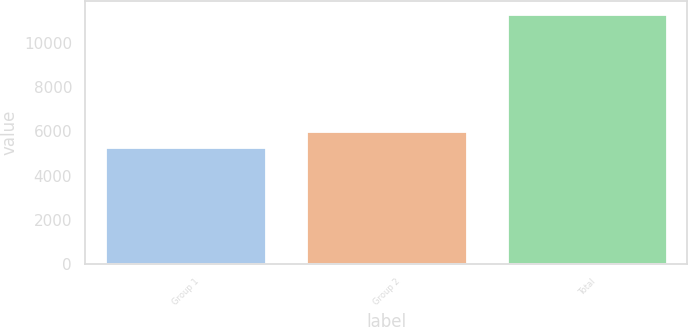<chart> <loc_0><loc_0><loc_500><loc_500><bar_chart><fcel>Group 1<fcel>Group 2<fcel>Total<nl><fcel>5286.3<fcel>6029.1<fcel>11315.4<nl></chart> 